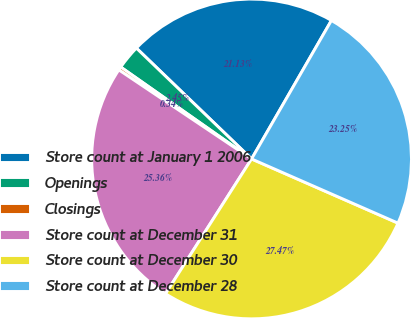Convert chart. <chart><loc_0><loc_0><loc_500><loc_500><pie_chart><fcel>Store count at January 1 2006<fcel>Openings<fcel>Closings<fcel>Store count at December 31<fcel>Store count at December 30<fcel>Store count at December 28<nl><fcel>21.13%<fcel>2.45%<fcel>0.34%<fcel>25.36%<fcel>27.47%<fcel>23.25%<nl></chart> 